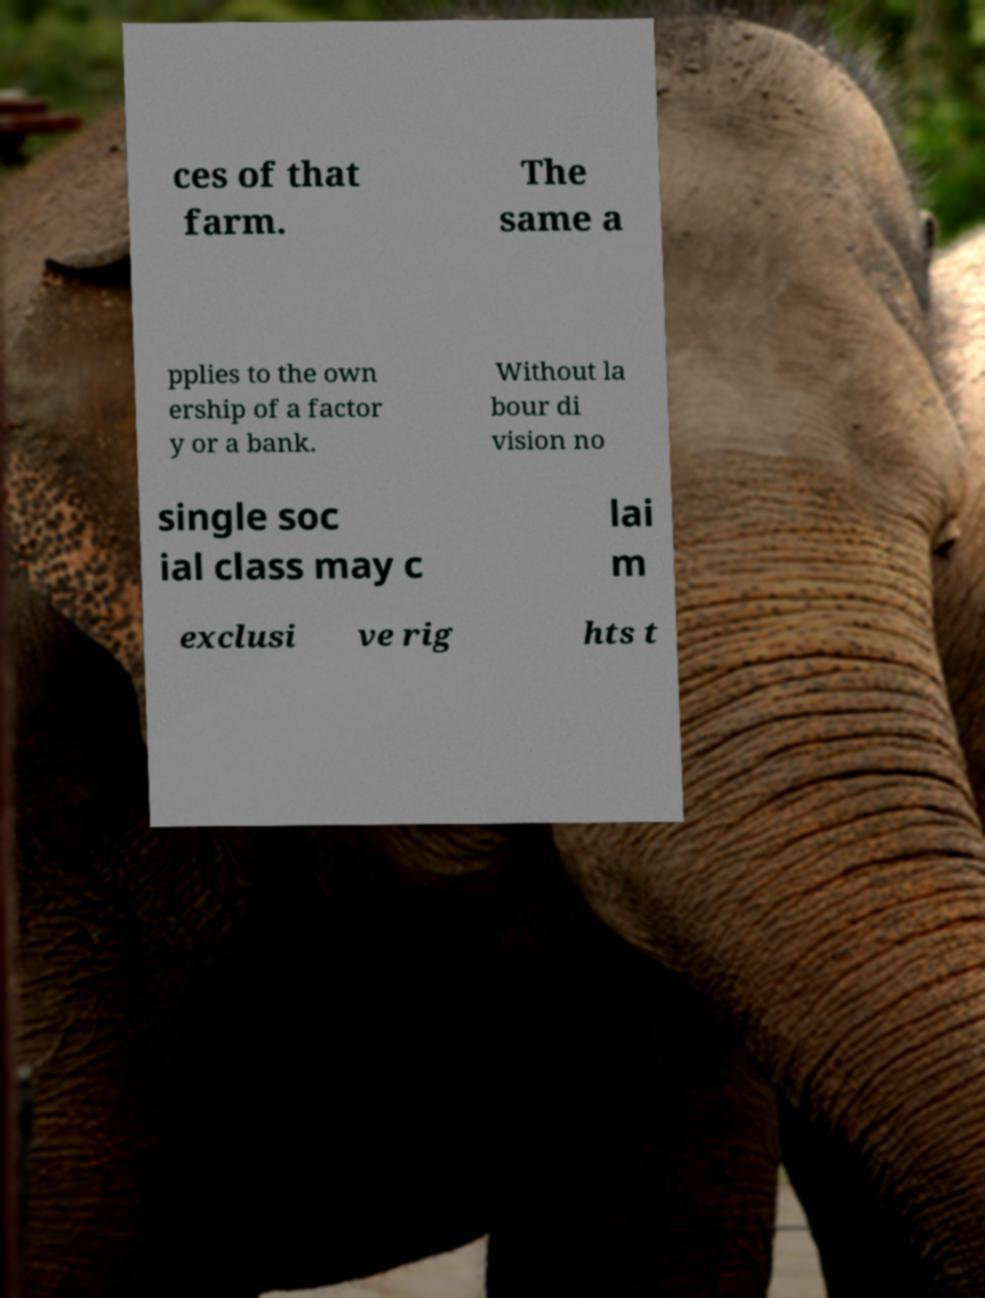Can you accurately transcribe the text from the provided image for me? ces of that farm. The same a pplies to the own ership of a factor y or a bank. Without la bour di vision no single soc ial class may c lai m exclusi ve rig hts t 